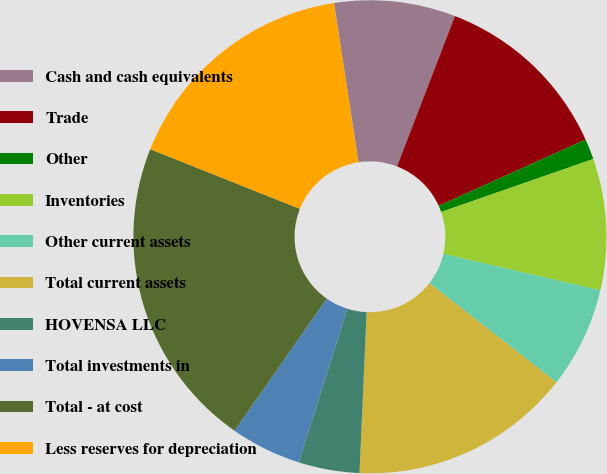<chart> <loc_0><loc_0><loc_500><loc_500><pie_chart><fcel>Cash and cash equivalents<fcel>Trade<fcel>Other<fcel>Inventories<fcel>Other current assets<fcel>Total current assets<fcel>HOVENSA LLC<fcel>Total investments in<fcel>Total - at cost<fcel>Less reserves for depreciation<nl><fcel>8.28%<fcel>12.41%<fcel>1.41%<fcel>8.97%<fcel>6.91%<fcel>15.16%<fcel>4.16%<fcel>4.84%<fcel>21.34%<fcel>16.53%<nl></chart> 